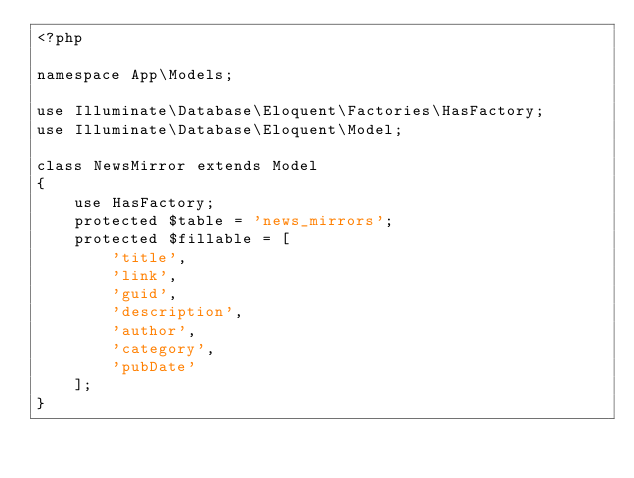Convert code to text. <code><loc_0><loc_0><loc_500><loc_500><_PHP_><?php

namespace App\Models;

use Illuminate\Database\Eloquent\Factories\HasFactory;
use Illuminate\Database\Eloquent\Model;

class NewsMirror extends Model
{
    use HasFactory;
    protected $table = 'news_mirrors';
    protected $fillable = [
        'title',
        'link',
        'guid',
        'description',
        'author',
        'category',
        'pubDate'
    ];
}
</code> 